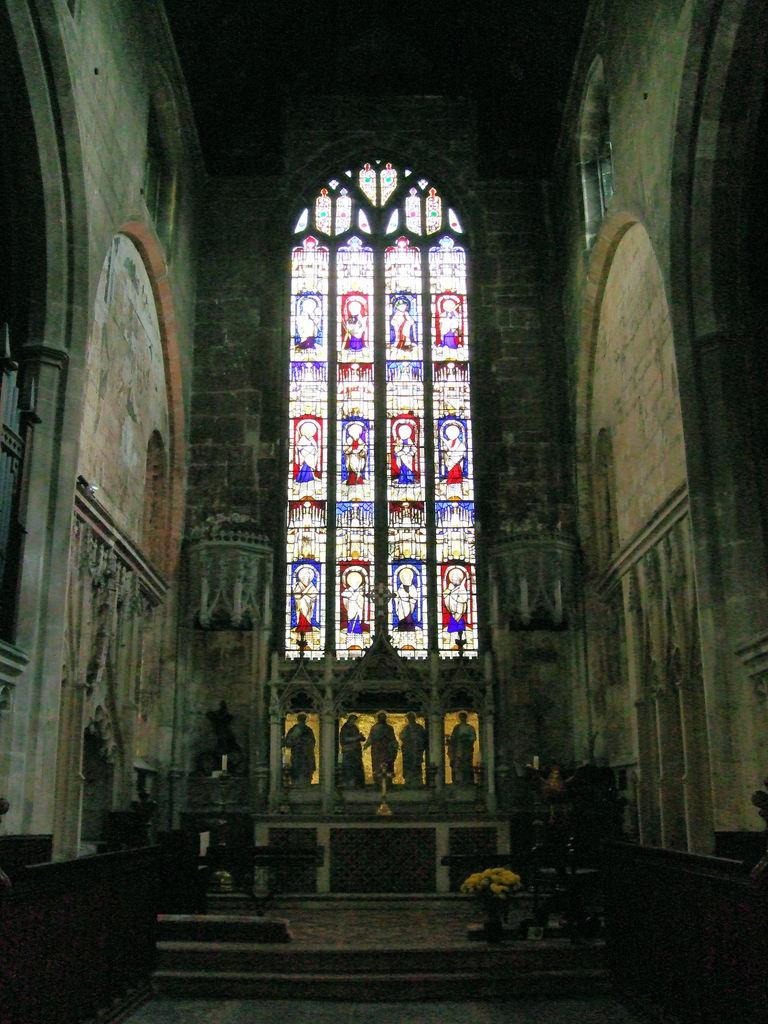What type of location is depicted in the image? The image shows the inside of a building. What kind of artwork can be seen in the image? There are sculptures in the image. How many objects are visible in the image? There are many objects in the image. Can you describe a unique feature of the objects in the image? There is a painting on the glasses in the image. What type of road can be seen in the image? There is no road visible in the image; it shows the inside of a building. What kind of wine is being served in the image? There is no wine present in the image. 